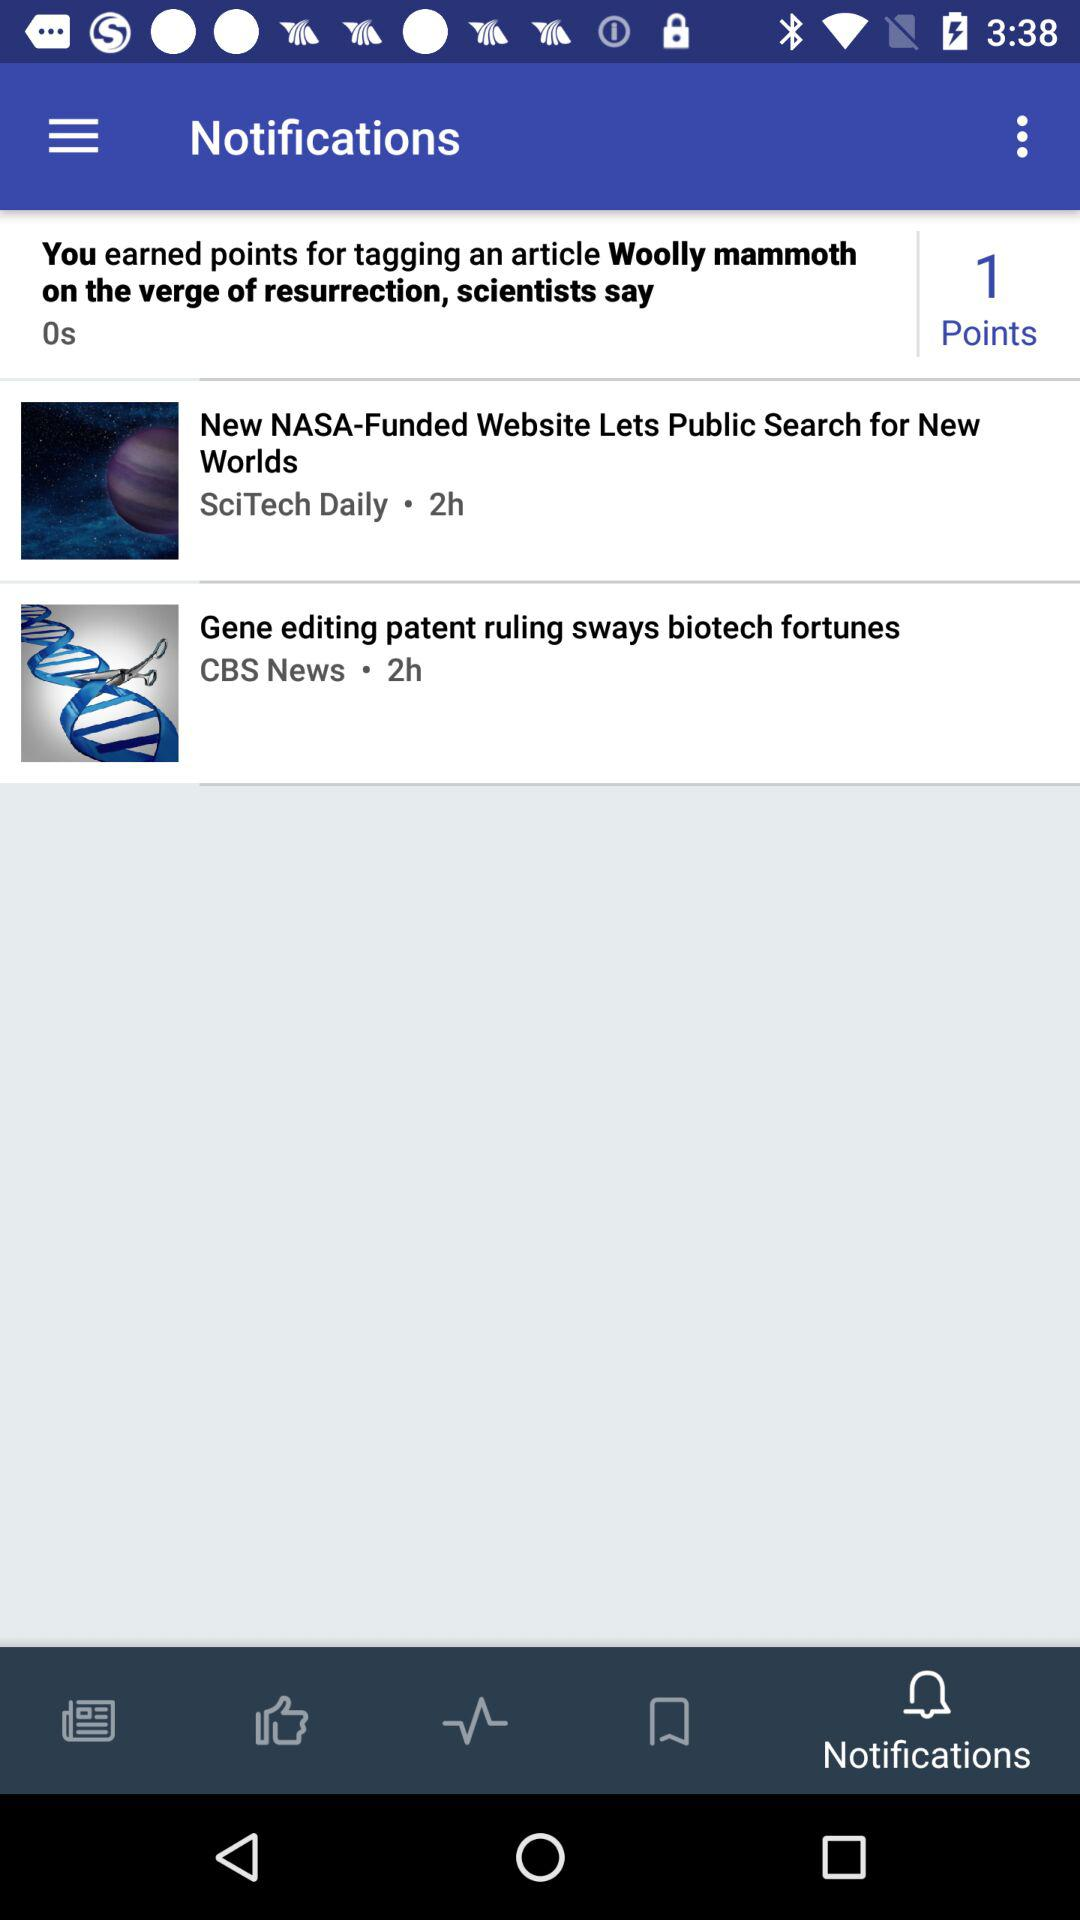How many hours ago did CBS news update a post? CBS news updated a post 2 hours ago. 